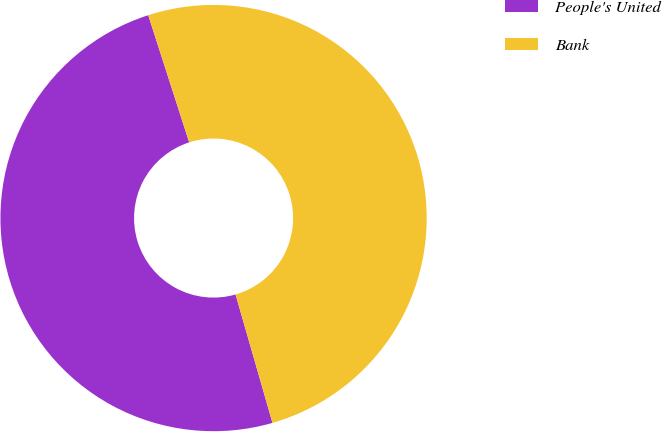Convert chart. <chart><loc_0><loc_0><loc_500><loc_500><pie_chart><fcel>People's United<fcel>Bank<nl><fcel>49.5%<fcel>50.5%<nl></chart> 